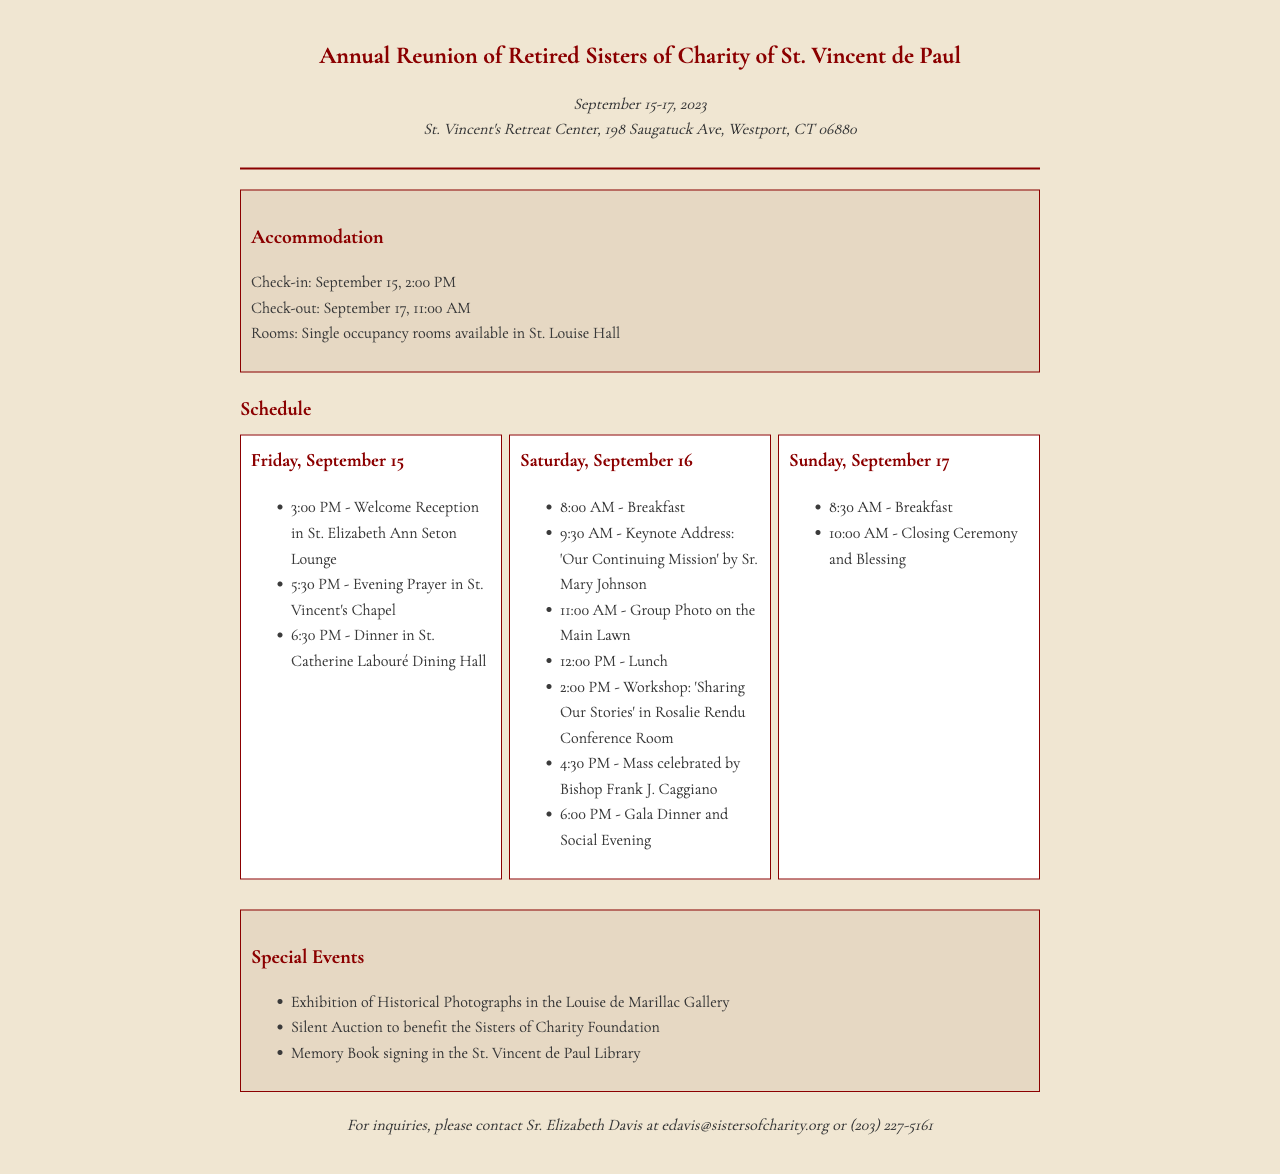What are the dates of the reunion? The reunion is scheduled for September 15-17, 2023 as mentioned in the document.
Answer: September 15-17, 2023 Where will the reunion take place? The location of the reunion is provided as St. Vincent's Retreat Center, Westport, CT.
Answer: St. Vincent's Retreat Center, Westport, CT What time does check-in begin? The document specifies that check-in starts at 2:00 PM on September 15.
Answer: 2:00 PM Who is the keynote speaker? The keynote speaker identified in the schedule is Sr. Mary Johnson.
Answer: Sr. Mary Johnson How many meals are scheduled for Saturday, September 16? The schedule lists a total of four meals: breakfast, lunch, and dinner, plus the evening gala dinner.
Answer: Four meals What special event features historical photographs? The document mentions an exhibition dedicated to historical photographs.
Answer: Exhibition of Historical Photographs What is the email contact for inquiries? The contact information lists an email for inquiries, which is provided in the document.
Answer: edavis@sistersofcharity.org What is the closing ceremony time on Sunday? The time for the closing ceremony is specified as 10:00 AM in the schedule.
Answer: 10:00 AM What is the title of the keynote address? The document lists the title of the keynote address as 'Our Continuing Mission'.
Answer: Our Continuing Mission 